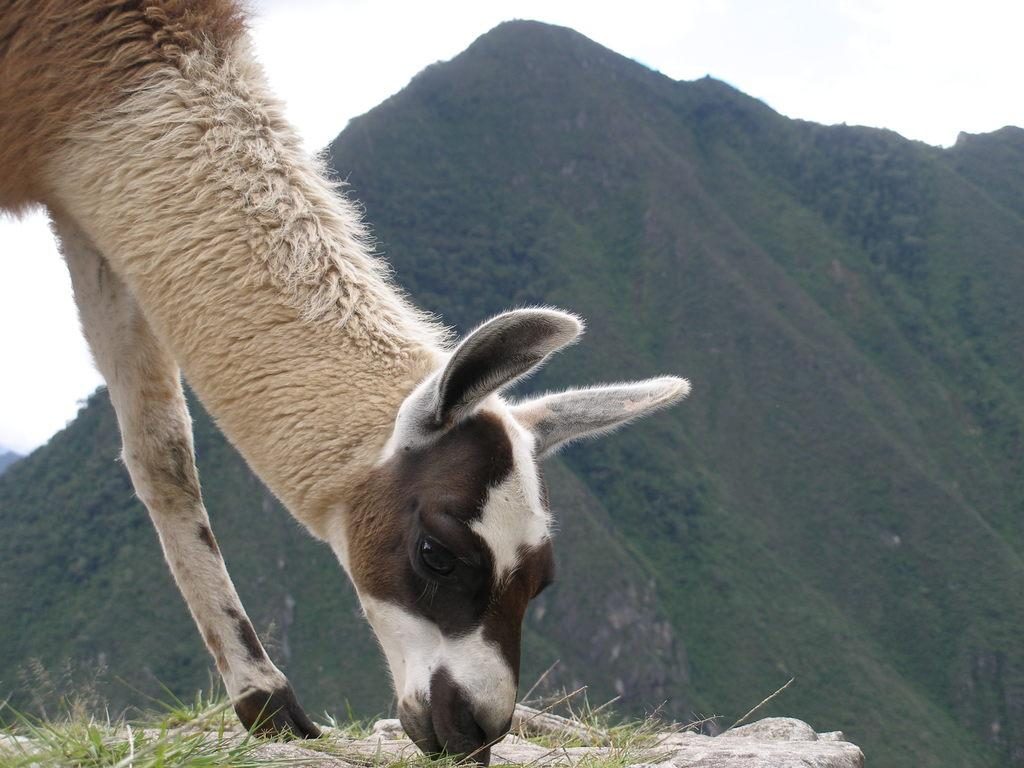What type of animal is present in the image? There is an animal in the image, but its specific type cannot be determined from the provided facts. What can be seen in the distance behind the animal? There is a mountain in the background of the image. What else is visible in the background of the image? The sky is visible in the background of the image. What type of lettuce is being served as a side dish with the meal in the image? There is no meal or lettuce present in the image; it features an animal and a mountain in the background. 